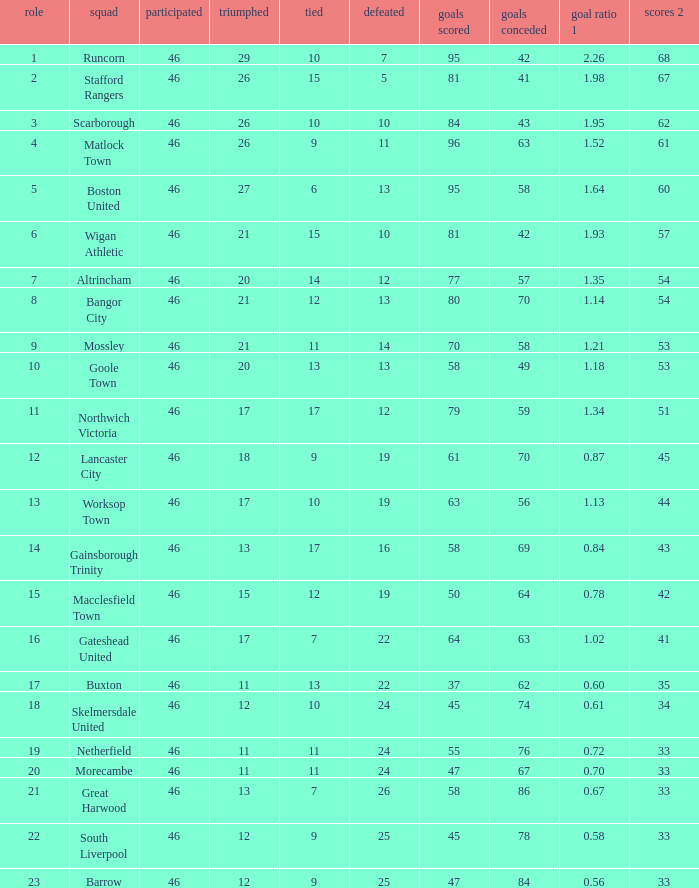What is the highest position of the Bangor City team? 8.0. Can you parse all the data within this table? {'header': ['role', 'squad', 'participated', 'triumphed', 'tied', 'defeated', 'goals scored', 'goals conceded', 'goal ratio 1', 'scores 2'], 'rows': [['1', 'Runcorn', '46', '29', '10', '7', '95', '42', '2.26', '68'], ['2', 'Stafford Rangers', '46', '26', '15', '5', '81', '41', '1.98', '67'], ['3', 'Scarborough', '46', '26', '10', '10', '84', '43', '1.95', '62'], ['4', 'Matlock Town', '46', '26', '9', '11', '96', '63', '1.52', '61'], ['5', 'Boston United', '46', '27', '6', '13', '95', '58', '1.64', '60'], ['6', 'Wigan Athletic', '46', '21', '15', '10', '81', '42', '1.93', '57'], ['7', 'Altrincham', '46', '20', '14', '12', '77', '57', '1.35', '54'], ['8', 'Bangor City', '46', '21', '12', '13', '80', '70', '1.14', '54'], ['9', 'Mossley', '46', '21', '11', '14', '70', '58', '1.21', '53'], ['10', 'Goole Town', '46', '20', '13', '13', '58', '49', '1.18', '53'], ['11', 'Northwich Victoria', '46', '17', '17', '12', '79', '59', '1.34', '51'], ['12', 'Lancaster City', '46', '18', '9', '19', '61', '70', '0.87', '45'], ['13', 'Worksop Town', '46', '17', '10', '19', '63', '56', '1.13', '44'], ['14', 'Gainsborough Trinity', '46', '13', '17', '16', '58', '69', '0.84', '43'], ['15', 'Macclesfield Town', '46', '15', '12', '19', '50', '64', '0.78', '42'], ['16', 'Gateshead United', '46', '17', '7', '22', '64', '63', '1.02', '41'], ['17', 'Buxton', '46', '11', '13', '22', '37', '62', '0.60', '35'], ['18', 'Skelmersdale United', '46', '12', '10', '24', '45', '74', '0.61', '34'], ['19', 'Netherfield', '46', '11', '11', '24', '55', '76', '0.72', '33'], ['20', 'Morecambe', '46', '11', '11', '24', '47', '67', '0.70', '33'], ['21', 'Great Harwood', '46', '13', '7', '26', '58', '86', '0.67', '33'], ['22', 'South Liverpool', '46', '12', '9', '25', '45', '78', '0.58', '33'], ['23', 'Barrow', '46', '12', '9', '25', '47', '84', '0.56', '33']]} 